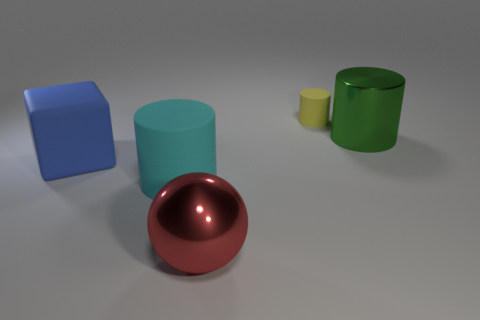Subtract all cyan cylinders. How many cylinders are left? 2 Subtract all cylinders. How many objects are left? 2 Add 3 brown metallic cylinders. How many objects exist? 8 Subtract all green cylinders. How many cylinders are left? 2 Add 2 blue rubber things. How many blue rubber things are left? 3 Add 5 matte things. How many matte things exist? 8 Subtract 0 green cubes. How many objects are left? 5 Subtract 1 balls. How many balls are left? 0 Subtract all green cubes. Subtract all red balls. How many cubes are left? 1 Subtract all purple balls. How many gray cylinders are left? 0 